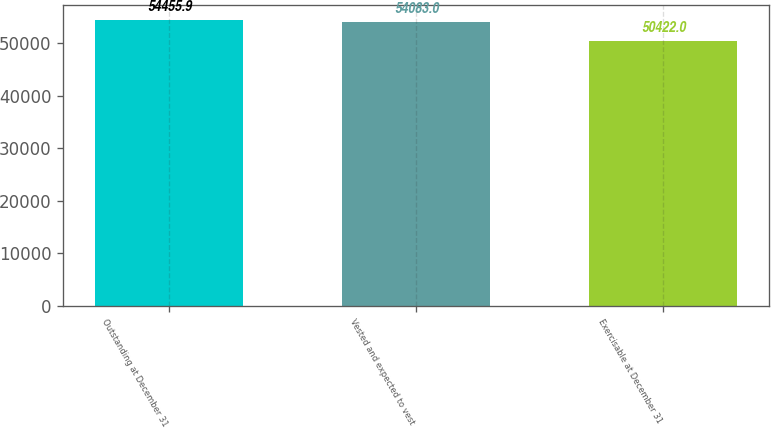Convert chart. <chart><loc_0><loc_0><loc_500><loc_500><bar_chart><fcel>Outstanding at December 31<fcel>Vested and expected to vest<fcel>Exercisable at December 31<nl><fcel>54455.9<fcel>54083<fcel>50422<nl></chart> 